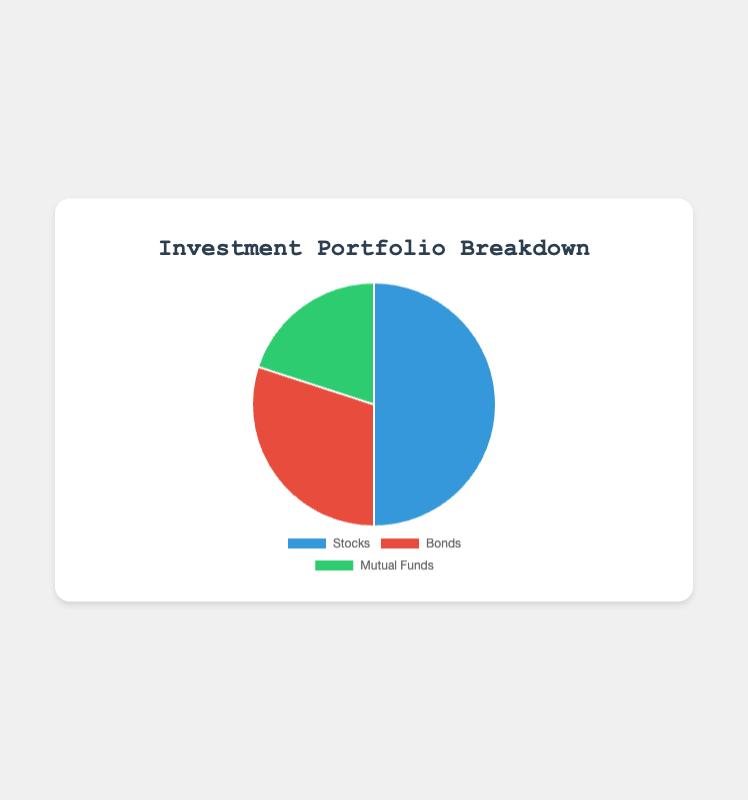What's the largest portion of the investment portfolio? The pie chart shows the percentage distribution of different investment types. The largest portion is indicated by the biggest slice, which is for Stocks at 50%.
Answer: Stocks Which investment type has the smallest percentage? By observing the pie chart, the slice with the smallest size represents Mutual Funds with 20%.
Answer: Mutual Funds How much more is invested in Stocks compared to Bonds? The percentage for Stocks is 50%, and for Bonds, it is 30%. The difference is 50% - 30% = 20%.
Answer: 20% If Bonds and Mutual Funds were combined, what percentage of the portfolio would they represent? The percentage for Bonds is 30%, and for Mutual Funds, it is 20%. Combined, they represent 30% + 20% = 50%.
Answer: 50% What is the color of the segment representing Stocks? The segment representing Stocks is colored blue.
Answer: Blue What is the ratio of the investment in Stocks to Mutual Funds? The percentage for Stocks is 50%, and for Mutual Funds, it is 20%. The ratio is 50:20, which simplifies to 5:2.
Answer: 5:2 How does the investment in Bonds compare visually to the investment in Mutual Funds? The slice representing Bonds is larger than the slice for Mutual Funds. Specifically, Bonds take up 30% of the chart, while Mutual Funds take up 20%.
Answer: Bonds slice is larger What percentage of the portfolio is comprised of equity investments? The only equity investments listed are Stocks, which represent 50% of the portfolio.
Answer: 50% What is the total investment percentage excluding Mutual Funds? The total percentage of the portfolio excluding Mutual Funds is the sum of Stocks and Bonds, which is 50% + 30% = 80%.
Answer: 80% 